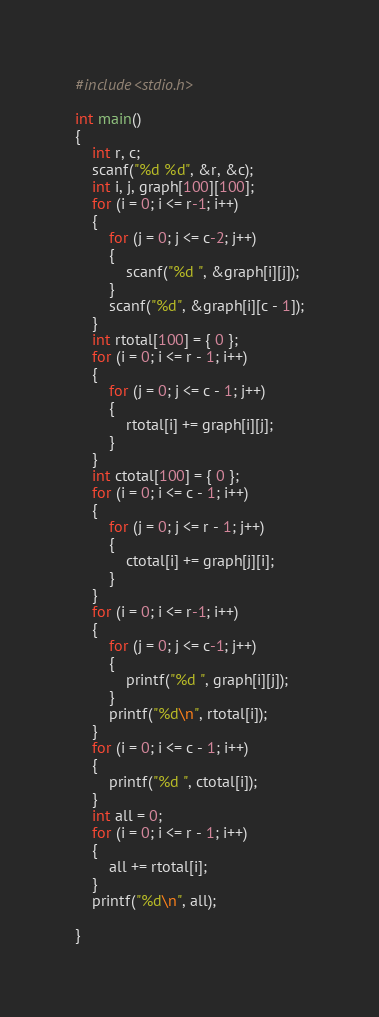Convert code to text. <code><loc_0><loc_0><loc_500><loc_500><_C++_>#include<stdio.h>

int main()
{
	int r, c;
	scanf("%d %d", &r, &c);
	int i, j, graph[100][100];
	for (i = 0; i <= r-1; i++)
	{
		for (j = 0; j <= c-2; j++)
		{
			scanf("%d ", &graph[i][j]);
		}
		scanf("%d", &graph[i][c - 1]);
	}
	int rtotal[100] = { 0 };
	for (i = 0; i <= r - 1; i++)
	{
		for (j = 0; j <= c - 1; j++)
		{
			rtotal[i] += graph[i][j];
		}
	}
	int ctotal[100] = { 0 };
	for (i = 0; i <= c - 1; i++)
	{
		for (j = 0; j <= r - 1; j++)
		{
			ctotal[i] += graph[j][i];
		}
	}
	for (i = 0; i <= r-1; i++)
	{
		for (j = 0; j <= c-1; j++)
		{
			printf("%d ", graph[i][j]);
		}
		printf("%d\n", rtotal[i]);
	}
	for (i = 0; i <= c - 1; i++)
	{
		printf("%d ", ctotal[i]);
	}
	int all = 0;
	for (i = 0; i <= r - 1; i++)
	{
		all += rtotal[i];
	}
	printf("%d\n", all);

}</code> 